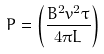Convert formula to latex. <formula><loc_0><loc_0><loc_500><loc_500>P = \left ( \frac { B ^ { 2 } v ^ { 2 } \tau } { 4 \pi L } \right )</formula> 